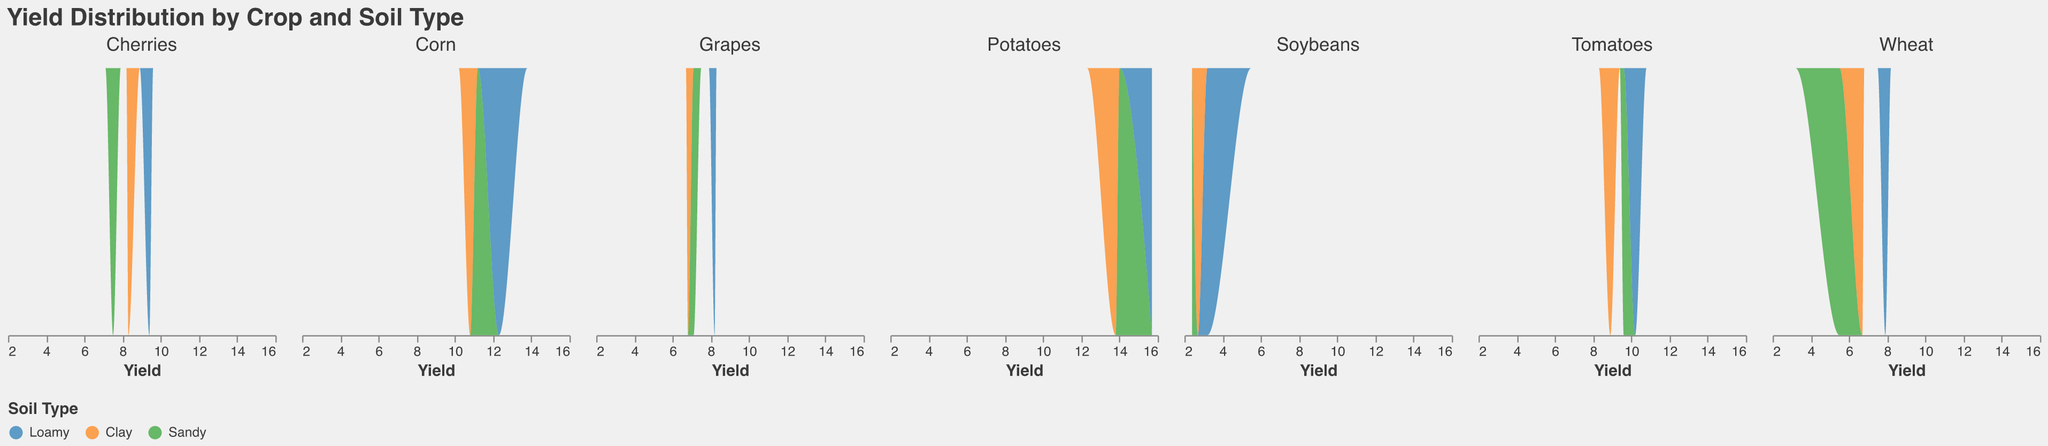What is the title of the plot? The title of the plot is provided at the top center of the figure and describes the content of the visualization.
Answer: Yield Distribution by Crop and Soil Type How many crops are displayed in the plot? Each column in the plot represents a different crop, and by counting the columns, we can determine the number of crops.
Answer: 7 Which crop has the highest overall yield value in any soil type? By looking at the maximum x-values for each subplot (representing different crops), we can find the highest yield value. The highest value is for Potatoes in the Snake River Plain region.
Answer: Potatoes For Grapes, which soil type shows the highest yield distribution? The highest yield distribution for Grapes can be identified by looking at which color (representing different soil types) extends furthest to the right in the Grapes subplot.
Answer: Loamy In which region do Cherries have the highest yield and what is the soil type there? By examining the Cherries subplot and identifying the maximum yield, we can determine the highest yield and the corresponding soil type.
Answer: Willamette Valley, Loamy How does the yield distribution for Sandy soil compare between Corn and Soybeans? Compare the extent of the green area (representing Sandy soil) in the subplots for Corn and Soybeans. For Corn, the green area peaks around 11.2, whereas for Soybeans, it peaks around 2.4.
Answer: Corn has a higher distribution Which crops show higher yield distributions with Loamy soil consistently across regions? By analyzing the subplots and observing where the blue areas (representing Loamy soil) are consistently towards the higher end of the yield axis, we identify which crops have higher yields with Loamy soil.
Answer: Grapes, Cherries, Tomatoes, Corn, Potatoes What is the typical range of yields for Wheat in Clay soil? The typical range can be determined by examining the extent of the orange area (representing Clay soil) in the Wheat subplot.
Answer: 6.7 How does the yield distribution of Potatoes in Sandy soil compare to that in Clay soil? By comparing the green and orange areas in the Potatoes subplot, we can see the ranges and peak distributions. The green area represents Sandy soil and peaks around 14, while the orange area for Clay soil peaks around 13.8.
Answer: Similar, but Sandy soil slightly higher Which regions have the most varied yield distributions across soil types? By observing the range and overlap of different colored areas in the subplots, we can deduce which regions have the most varied distributions.
Answer: Great Plains, Red River Valley 